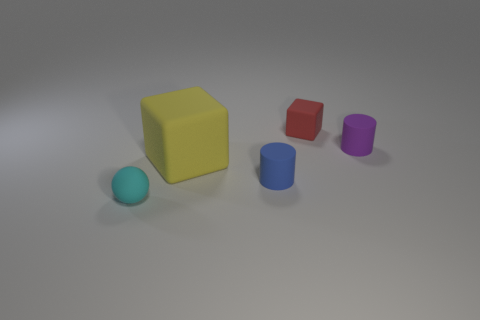Add 4 small green cubes. How many objects exist? 9 Subtract all cubes. How many objects are left? 3 Add 2 small green metal objects. How many small green metal objects exist? 2 Subtract 0 red balls. How many objects are left? 5 Subtract all cyan matte balls. Subtract all small purple cylinders. How many objects are left? 3 Add 5 cyan balls. How many cyan balls are left? 6 